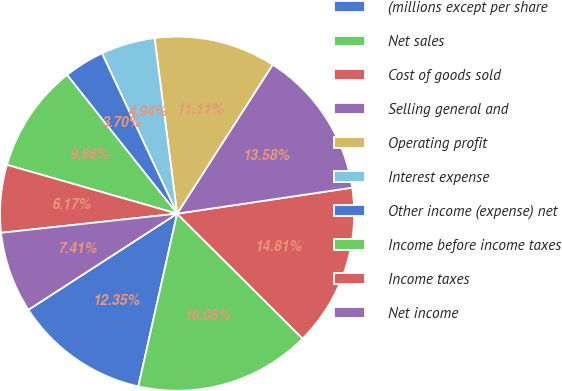<chart> <loc_0><loc_0><loc_500><loc_500><pie_chart><fcel>(millions except per share<fcel>Net sales<fcel>Cost of goods sold<fcel>Selling general and<fcel>Operating profit<fcel>Interest expense<fcel>Other income (expense) net<fcel>Income before income taxes<fcel>Income taxes<fcel>Net income<nl><fcel>12.35%<fcel>16.05%<fcel>14.81%<fcel>13.58%<fcel>11.11%<fcel>4.94%<fcel>3.7%<fcel>9.88%<fcel>6.17%<fcel>7.41%<nl></chart> 